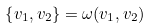<formula> <loc_0><loc_0><loc_500><loc_500>\left \{ v _ { 1 } , v _ { 2 } \right \} = \omega ( v _ { 1 } , v _ { 2 } )</formula> 